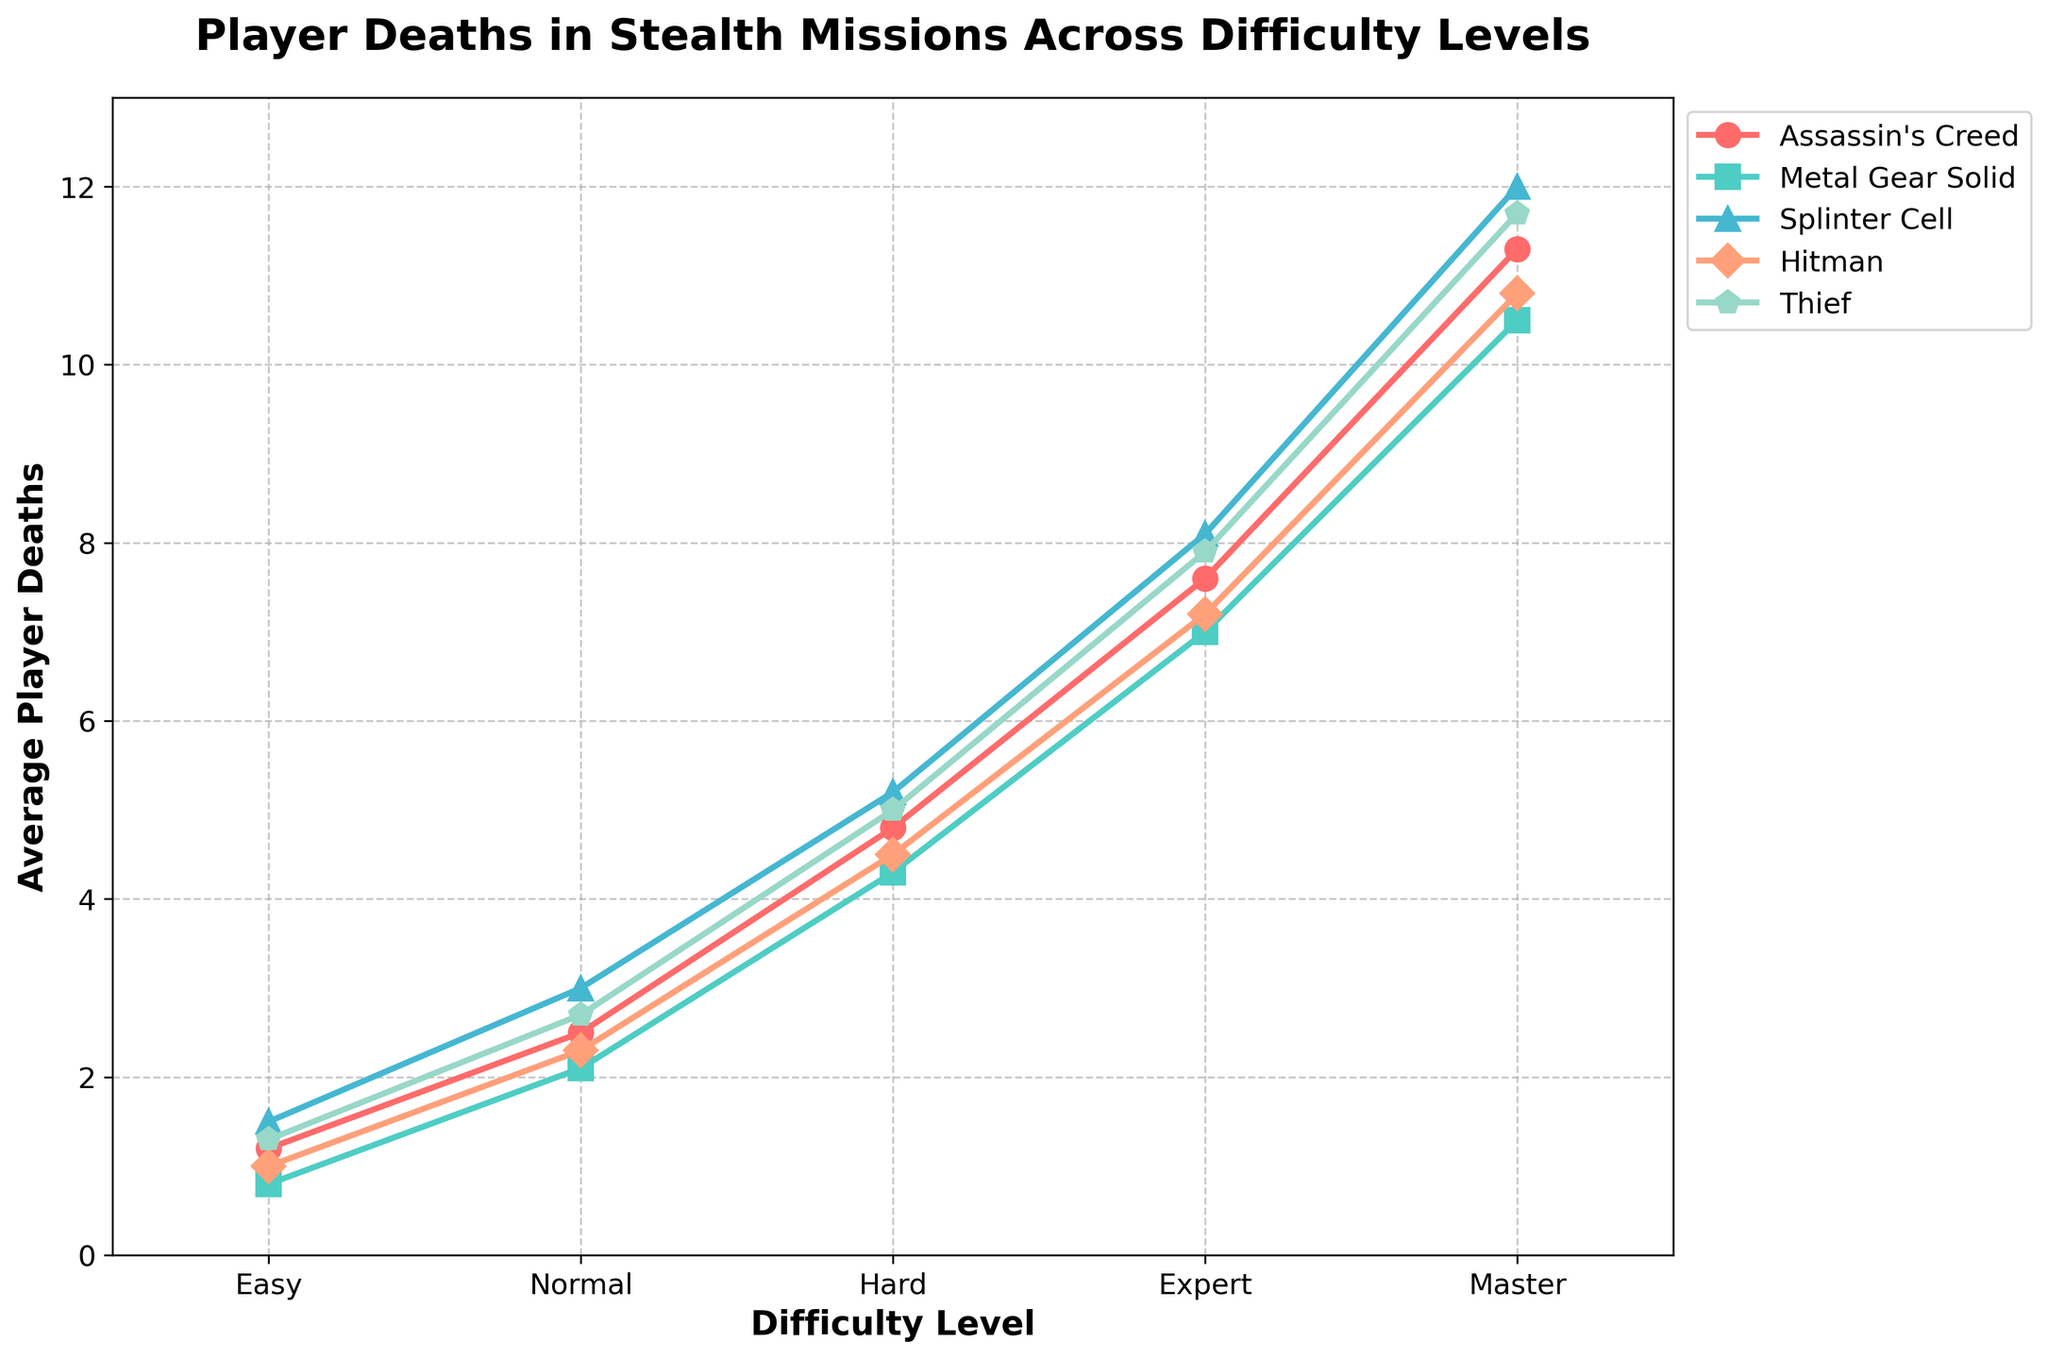What's the highest number of player deaths recorded across all difficulty levels and games? To find the highest number of player deaths, look at the data points for all difficulty levels and all games. The highest number is 12.0 deaths at the Master difficulty level for Splinter Cell.
Answer: 12.0 Which game has the lowest player deaths on the Expert difficulty level? Check the player deaths for each game at the Expert difficulty level. Metal Gear Solid has the lowest player deaths with 7.0.
Answer: Metal Gear Solid By how much do player deaths increase from Normal to Hard difficulty for Assassin's Creed? Subtract the number of player deaths at Normal difficulty for Assassin's Creed (2.5) from the deaths at Hard difficulty (4.8). The increase is 4.8 - 2.5 = 2.3.
Answer: 2.3 Is the increase in player deaths between Hard and Expert difficulty levels greater for Hitman or Thief? Calculate the difference in player deaths for Hard to Expert difficulty for both games. For Hitman, the increase is 7.2 - 4.5 = 2.7. For Thief, the increase is 7.9 - 5.0 = 2.9. Thief has a greater increase.
Answer: Thief What's the average number of player deaths on the Hard difficulty level across all games? Sum the number of player deaths on Hard difficulty for all games and divide by the number of games. (4.8 + 4.3 + 5.2 + 4.5 + 5.0) / 5 = 23.8 / 5 = 4.76.
Answer: 4.76 Which game shows the steepest increase in player deaths from Easy to Master difficulty? Calculate the difference in player deaths from Easy to Master for each game. Assassin's Creed: 11.3 - 1.2 = 10.1, Metal Gear Solid: 10.5 - 0.8 = 9.7, Splinter Cell: 12.0 - 1.5 = 10.5, Hitman: 10.8 - 1.0 = 9.8, Thief: 11.7 - 1.3 = 10.4. Splinter Cell shows the steepest increase with 10.5.
Answer: Splinter Cell At which difficulty level do all games show a player death count higher than 2? Check the player deaths for each game at every difficulty level. All games show player deaths higher than 2 starting from Normal difficulty onwards.
Answer: Normal Which game's player deaths trend most closely follows Assassin's Creed across the difficulty levels? Visually compare the trend lines of each game with Assassin's Creed. Thief shows a trend line that closely follows that of Assassin's Creed.
Answer: Thief How much higher are the player deaths for Splinter Cell at Expert difficulty compared to Metal Gear Solid at the same difficulty? Subtract the number of player deaths for Metal Gear Solid at Expert difficulty (7.0) from Splinter Cell at Expert difficulty (8.1). The difference is 8.1 - 7.0 = 1.1.
Answer: 1.1 What is the range of player deaths for Hitman across all difficulty levels? Find the difference between the highest and lowest player deaths for Hitman. The highest is 10.8 at Master difficulty and the lowest is 1.0 at Easy difficulty. The range is 10.8 - 1.0 = 9.8.
Answer: 9.8 